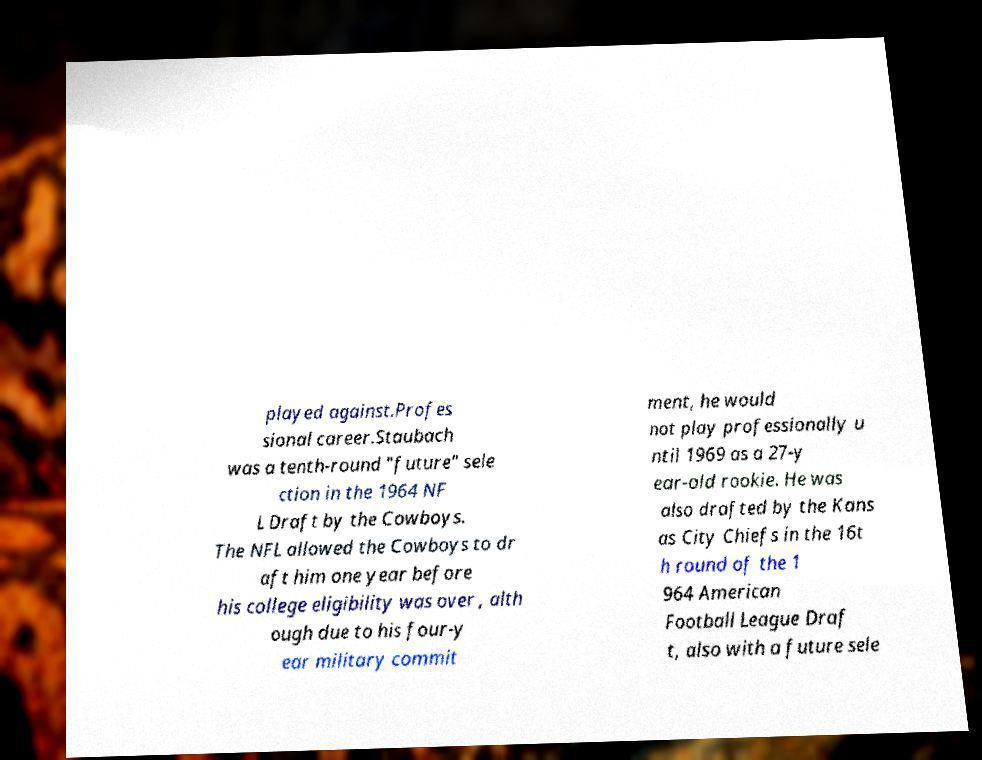Please read and relay the text visible in this image. What does it say? played against.Profes sional career.Staubach was a tenth-round "future" sele ction in the 1964 NF L Draft by the Cowboys. The NFL allowed the Cowboys to dr aft him one year before his college eligibility was over , alth ough due to his four-y ear military commit ment, he would not play professionally u ntil 1969 as a 27-y ear-old rookie. He was also drafted by the Kans as City Chiefs in the 16t h round of the 1 964 American Football League Draf t, also with a future sele 